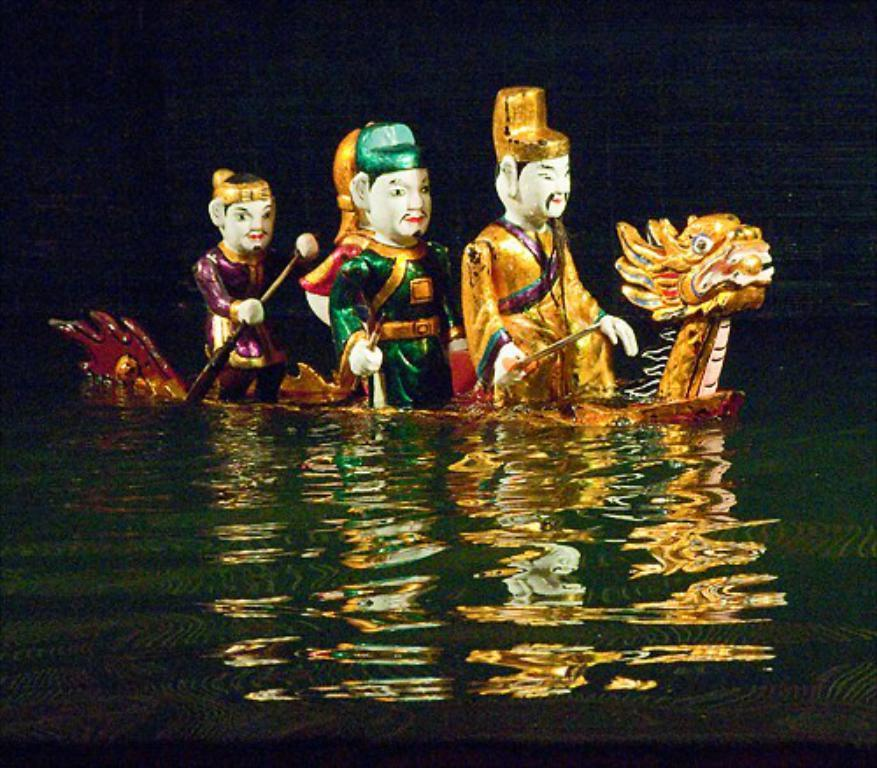What objects can be seen floating in the water in the image? There are floating toys in the water. What can be observed about the background of the image? The background of the image is dark. What type of support can be seen in the image? There is no support visible in the image; it only features floating toys in the water and a dark background. What sound can be heard coming from the toys in the image? There is no sound present in the image, as it is a still image and not a video or audio recording. 